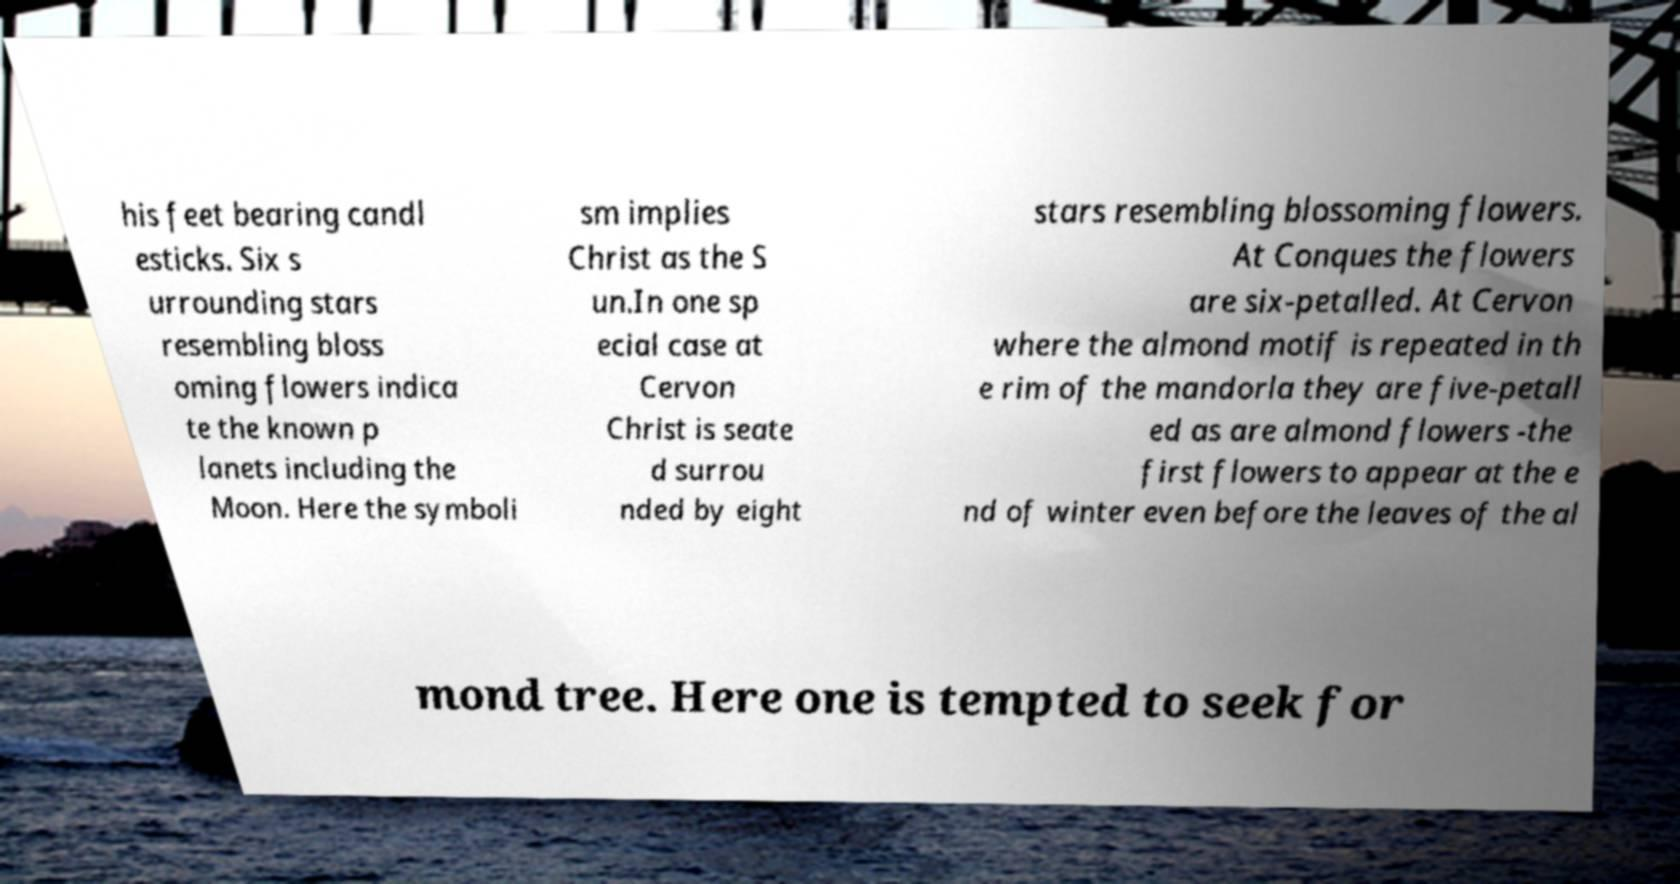Could you extract and type out the text from this image? his feet bearing candl esticks. Six s urrounding stars resembling bloss oming flowers indica te the known p lanets including the Moon. Here the symboli sm implies Christ as the S un.In one sp ecial case at Cervon Christ is seate d surrou nded by eight stars resembling blossoming flowers. At Conques the flowers are six-petalled. At Cervon where the almond motif is repeated in th e rim of the mandorla they are five-petall ed as are almond flowers -the first flowers to appear at the e nd of winter even before the leaves of the al mond tree. Here one is tempted to seek for 